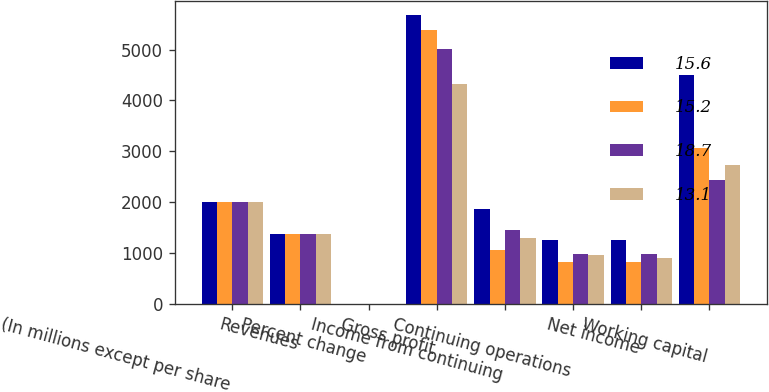<chart> <loc_0><loc_0><loc_500><loc_500><stacked_bar_chart><ecel><fcel>(In millions except per share<fcel>Revenues<fcel>Percent change<fcel>Gross profit<fcel>Income from continuing<fcel>Continuing operations<fcel>Net income<fcel>Working capital<nl><fcel>15.6<fcel>2010<fcel>1377<fcel>1.9<fcel>5676<fcel>1864<fcel>1263<fcel>1263<fcel>4492<nl><fcel>15.2<fcel>2009<fcel>1377<fcel>4.8<fcel>5378<fcel>1064<fcel>823<fcel>823<fcel>3065<nl><fcel>18.7<fcel>2008<fcel>1377<fcel>9.4<fcel>5009<fcel>1457<fcel>989<fcel>990<fcel>2438<nl><fcel>13.1<fcel>2007<fcel>1377<fcel>6.9<fcel>4332<fcel>1297<fcel>968<fcel>913<fcel>2730<nl></chart> 